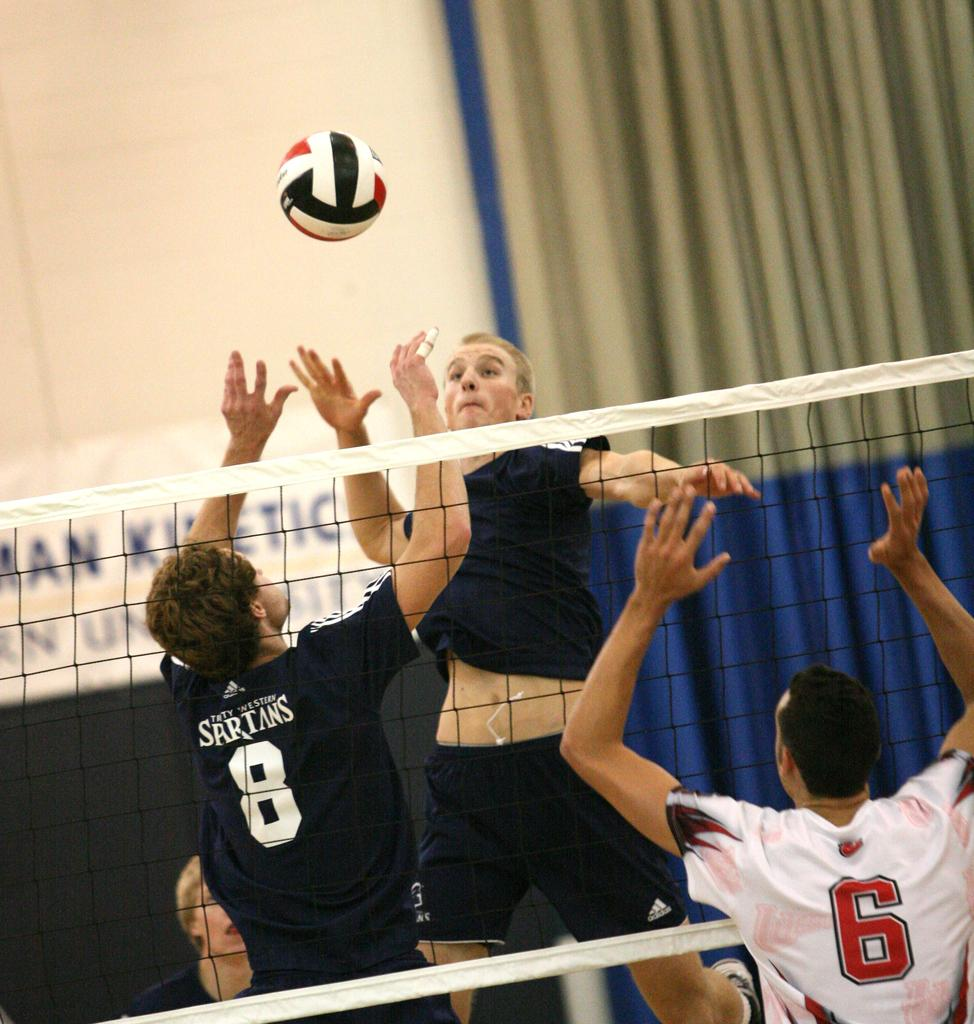What activity are the persons in the image engaged in? The persons in the image are playing throw ball. What is the surface on which the game is being played? There is a mesh in the image, which is likely the surface for playing throw ball. What can be seen in the background of the image? There is a curtain in the background of the image. What type of fiction is being read by the persons in the image? There is no indication in the image that the persons are reading any fiction. How many vans are visible in the image? There are no vans present in the image. 